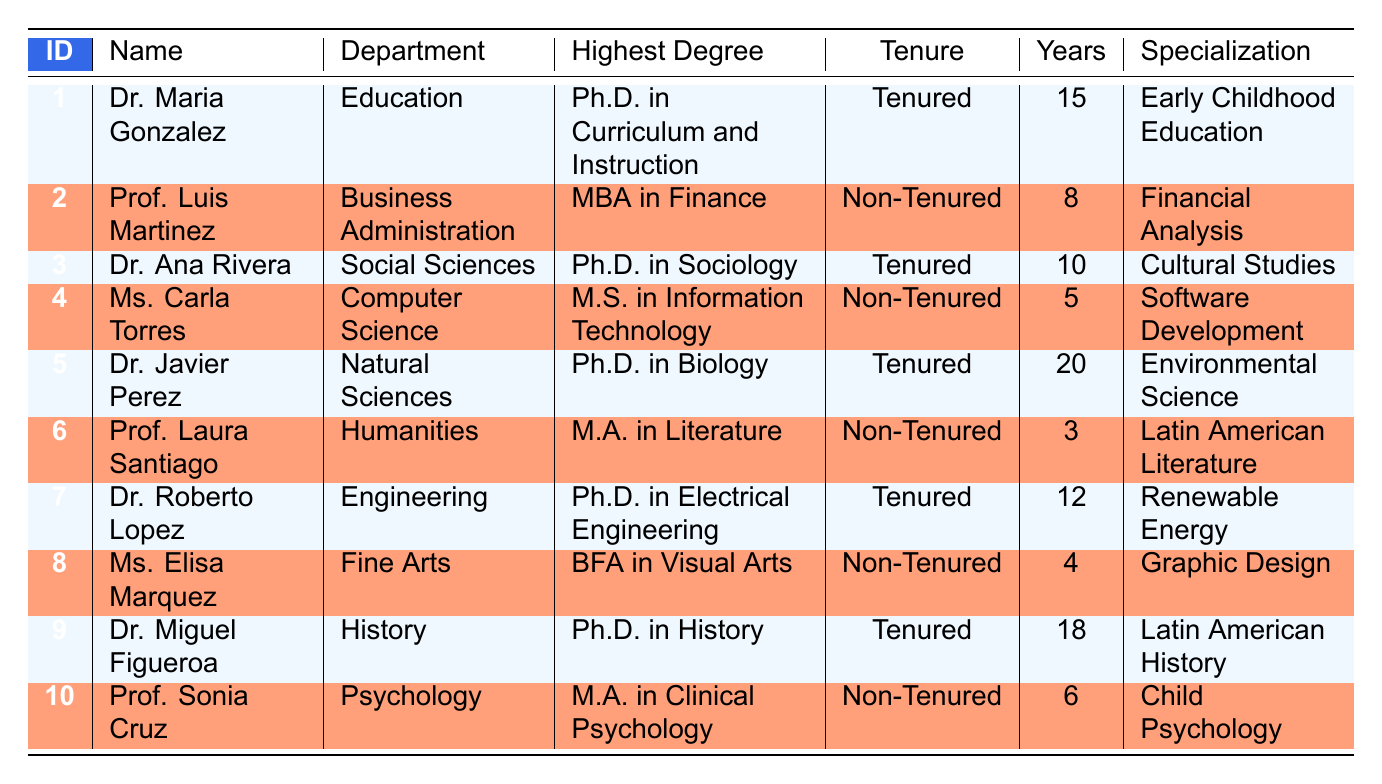What is the highest degree attained by Dr. Maria Gonzalez? Looking at the row for Dr. Maria Gonzalez, the column for Highest Degree shows "Ph.D. in Curriculum and Instruction".
Answer: Ph.D. in Curriculum and Instruction How many years of experience does Prof. Luis Martinez have? In the row for Prof. Luis Martinez, the Years column indicates "8".
Answer: 8 Which faculty member has a specialization in Renewable Energy? Dr. Roberto Lopez's specialization is listed as Renewable Energy in the specialization column.
Answer: Dr. Roberto Lopez Is there a faculty member in the Fine Arts department who is tenured? By checking the tenure status of Ms. Elisa Marquez in the Fine Arts department, the status is "Non-Tenured", which indicates there is no faculty member in Fine Arts who is tenured.
Answer: No What is the average years of experience for tenured faculty members? There are five tenured faculty members: Dr. Maria Gonzalez (15), Dr. Ana Rivera (10), Dr. Javier Perez (20), Dr. Roberto Lopez (12), and Dr. Miguel Figueroa (18). The sum of their years is 15 + 10 + 20 + 12 + 18 = 85, and there are 5 tenured faculty members. Therefore, the average is 85 / 5 = 17.
Answer: 17 Which faculty member has the highest years of experience? Among the faculty members, checking the years of experience, Dr. Javier Perez has 20 years, which is the highest.
Answer: Dr. Javier Perez How many faculty members have a Master’s degree? Examining the data, two faculty members hold a Master’s degree: Prof. Luis Martinez (MBA in Finance) and Prof. Laura Santiago (M.A. in Literature). Thus, there are two faculty members with Master’s degrees.
Answer: 2 What is the tenure status of Dr. Miguel Figueroa? In the data for Dr. Miguel Figueroa, the Tenure column shows "Tenured".
Answer: Tenured Which departments have faculty members who specialize in education-related fields? By reviewing the data, the Education department represented by Dr. Maria Gonzalez specializes in Early Childhood Education, while the Psychology department represented by Prof. Sonia Cruz specializes in Child Psychology. Therefore, these two departments focus on education-related fields.
Answer: Education, Psychology 